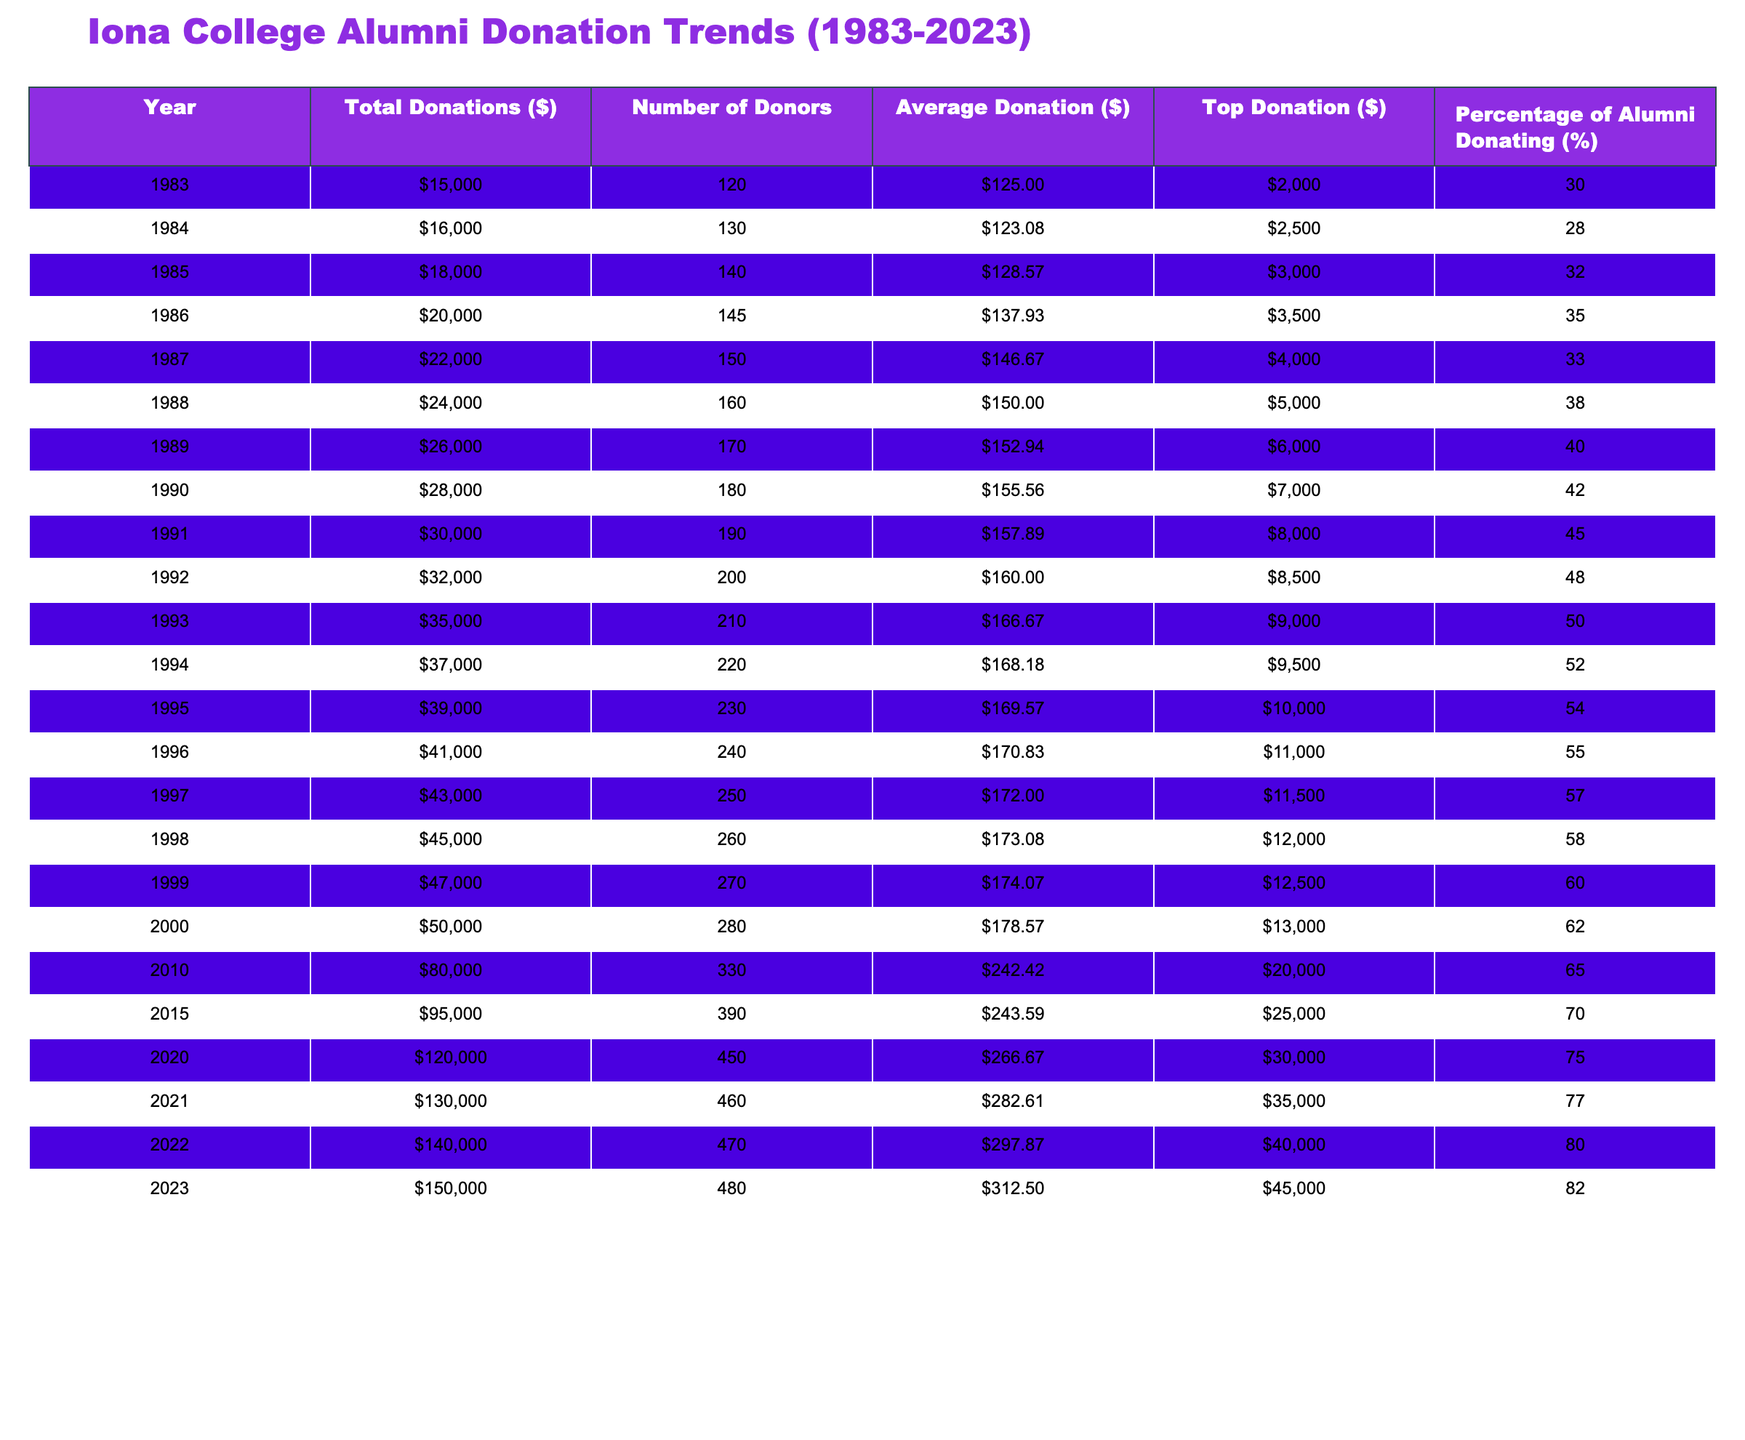What was the total amount of donations in 1990? In the row corresponding to the year 1990, the total donations listed are $28,000.
Answer: 28000 Which year had the highest average donation? Looking at the 'Average Donation ($)' column, the highest value is $312.50 in 2023.
Answer: 312.50 What is the percentage of alumni donating in 2015? In the year 2015, the percentage of alumni donating is listed as 70%.
Answer: 70% How many more donors were there in 2023 compared to 1983? In 2023, there were 480 donors, and in 1983, there were 120 donors. The difference is 480 - 120 = 360.
Answer: 360 What was the total donation amount for the years 2010 to 2023? Summing the total donations from 2010 to 2023 yields: $80,000 + $95,000 + $120,000 + $130,000 + $140,000 + $150,000 = $715,000.
Answer: 715000 Did the percentage of alumni donating increase every year from 1983 to 2023? The percentage of alumni donating increased from 30% in 1983 to 82% in 2023 without any decreases in those years.
Answer: Yes Which year had the largest single donation? The largest single donation listed was $45,000 in 2023.
Answer: 45000 What is the average donation for the years 2000 to 2023? Calculating the average donation for these years involves summing the average donations: $178.57 + $242.42 + $243.59 + $266.67 + $282.61 + $297.87 + $312.50 = $183.93. There are 7 years so we divide $1,848.23 by 7 which results in approximately $264.04.
Answer: 264.04 